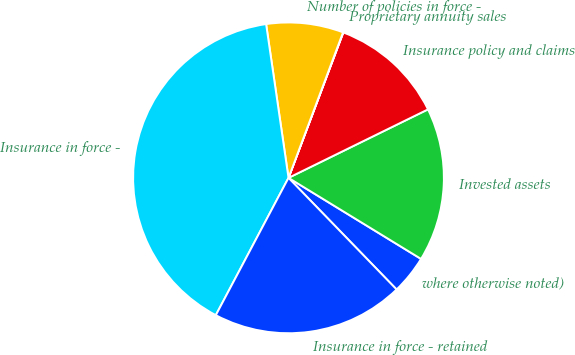Convert chart to OTSL. <chart><loc_0><loc_0><loc_500><loc_500><pie_chart><fcel>where otherwise noted)<fcel>Invested assets<fcel>Insurance policy and claims<fcel>Proprietary annuity sales<fcel>Number of policies in force -<fcel>Insurance in force -<fcel>Insurance in force - retained<nl><fcel>4.02%<fcel>16.0%<fcel>12.0%<fcel>0.03%<fcel>8.01%<fcel>39.95%<fcel>19.99%<nl></chart> 